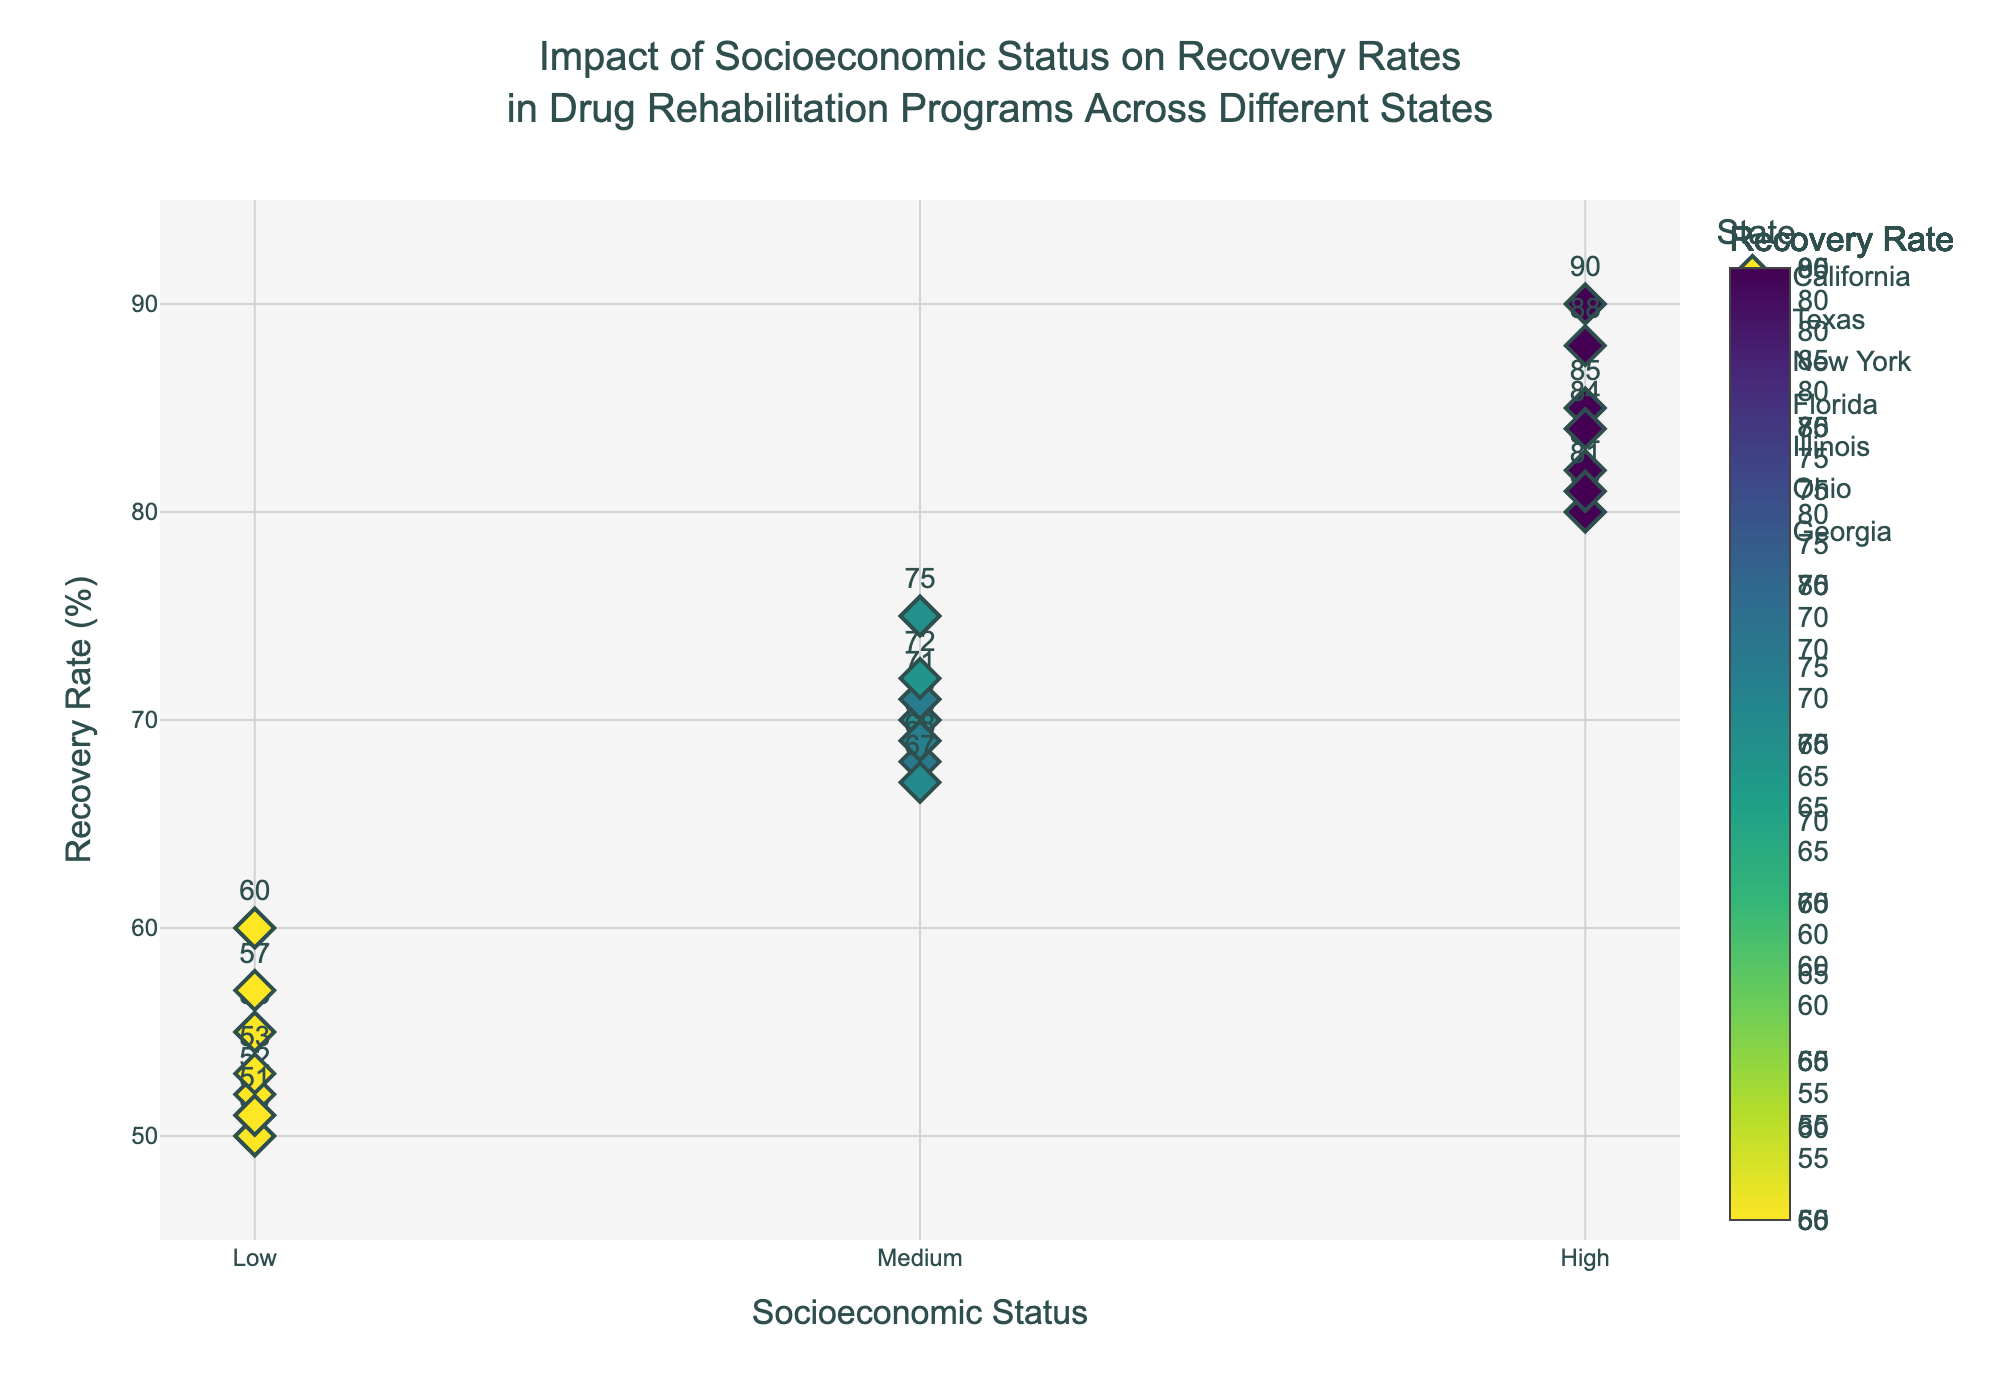Which state has the lowest recovery rate for the low socioeconomic status group? Identify the markers for the 'Low' socioeconomic status group and compare their recovery rates. Texas has the lowest recovery rate (50%).
Answer: Texas How does the recovery rate for medium socioeconomic status compare between Illinois and Georgia? Identify the markers for the 'Medium' socioeconomic status group within Illinois and Georgia. Illinois has a recovery rate of 71%, while Georgia has 67%. Therefore, Illinois has a higher recovery rate than Georgia.
Answer: Illinois has a higher recovery rate What is the average recovery rate for the high socioeconomic status group across all states? Calculate the average of the recovery rates in the 'High' socioeconomic status markers. (85 + 80 + 90 + 82 + 84 + 88 + 81) / 7 = 84.29%
Answer: 84.29% Which state shows the highest increase in recovery rate from low to high socioeconomic status? Compute the difference between the recovery rates for the 'High' and 'Low' markers within each state and find the state with the greatest difference. New York has the highest increase (90 - 60 = 30).
Answer: New York Is there any state where the recovery rate for the medium socioeconomic status is closer to the high socioeconomic status than to the low socioeconomic status? Compare the differences between the medium and both high and low socioeconomic statuses for each state. In each state, identify if the difference between medium and high is less than the difference between medium and low. For instance, in California: (85 - 70) < (70 - 55). Repeating for all states, we find that Ohio and New York meet this condition.
Answer: Ohio and New York Which state has the most similar recovery rates across all socioeconomic status groups? Calculate the range (highest - lowest recovery rate) within each state and identify the state with the smallest range. For example, Ohio: (88 - 57) = 31. Repeat calculations for each state and find the smallest range. Illinois has the smallest range.
Answer: Illinois What is the difference in recovery rates between the highest and lowest socioeconomic statuses in Florida? Subtract the recovery rate of the 'Low' group from that of the 'High' group in Florida. (82 - 52) = 30.
Answer: 30 How does Georgia's high socioeconomic status recovery rate compare to Ohio's medium socioeconomic status recovery rate? Identify the markers for Georgia's 'High' and Ohio's 'Medium' socioeconomic statuses and compare their recovery rates. Georgia's high socioeconomic recovery rate is 81%, and Ohio's medium socioeconomic recovery rate is 72%. Therefore, Georgia's is higher.
Answer: Georgia's high is higher What is the overall trend observed in recovery rates as socioeconomic status increases? Analyze the general pattern in the scatter plot, noting the upward trend in recovery rates as the socioeconomic status goes from Low to High across different states.
Answer: Recovery rates generally increase with higher socioeconomic status 